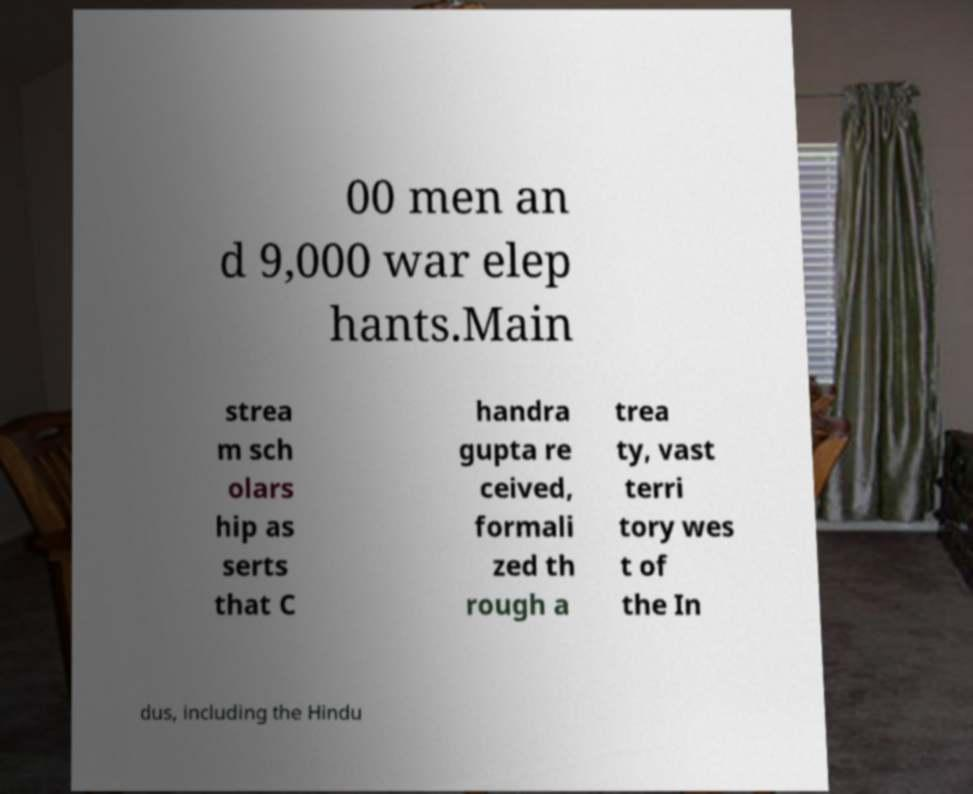For documentation purposes, I need the text within this image transcribed. Could you provide that? 00 men an d 9,000 war elep hants.Main strea m sch olars hip as serts that C handra gupta re ceived, formali zed th rough a trea ty, vast terri tory wes t of the In dus, including the Hindu 